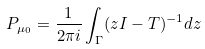Convert formula to latex. <formula><loc_0><loc_0><loc_500><loc_500>P _ { \mu _ { 0 } } = \frac { 1 } { 2 \pi i } \int _ { \Gamma } ( z I - T ) ^ { - 1 } d z</formula> 